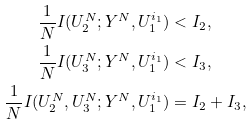<formula> <loc_0><loc_0><loc_500><loc_500>\frac { 1 } { N } I ( U _ { 2 } ^ { N } ; Y ^ { N } , U _ { 1 } ^ { i _ { 1 } } ) & < I _ { 2 } , \\ \frac { 1 } { N } I ( U _ { 3 } ^ { N } ; Y ^ { N } , U _ { 1 } ^ { i _ { 1 } } ) & < I _ { 3 } , \\ \frac { 1 } { N } I ( U _ { 2 } ^ { N } , U _ { 3 } ^ { N } ; Y ^ { N } , U _ { 1 } ^ { i _ { 1 } } ) & = I _ { 2 } + I _ { 3 } ,</formula> 